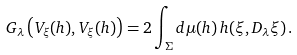<formula> <loc_0><loc_0><loc_500><loc_500>\ G _ { \lambda } \left ( V _ { \xi } ( h ) , V _ { \xi } ( h ) \right ) = 2 \int _ { \Sigma } d \mu ( h ) \, h ( \xi , D _ { \lambda } \xi ) \, .</formula> 